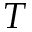Convert formula to latex. <formula><loc_0><loc_0><loc_500><loc_500>T</formula> 